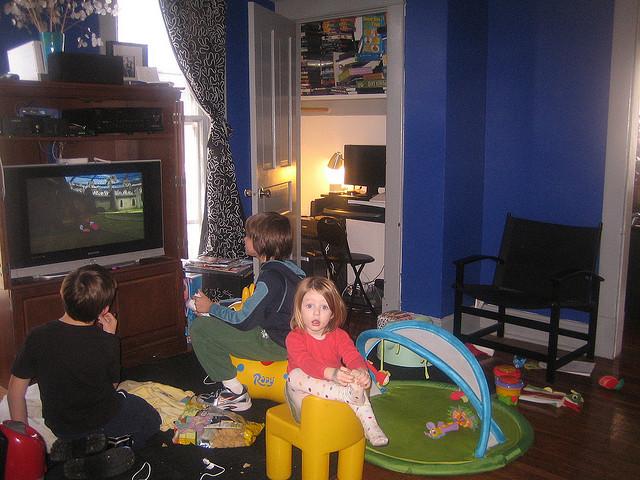How many kids are watching the TV?
Short answer required. 2. Is this place cluttered?
Give a very brief answer. Yes. Are these teenagers?
Concise answer only. No. 